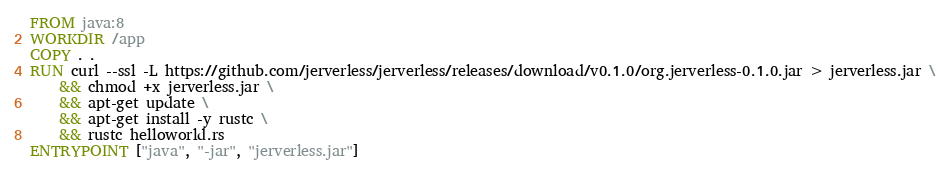<code> <loc_0><loc_0><loc_500><loc_500><_Dockerfile_>FROM java:8
WORKDIR /app
COPY . .
RUN curl --ssl -L https://github.com/jerverless/jerverless/releases/download/v0.1.0/org.jerverless-0.1.0.jar > jerverless.jar \
    && chmod +x jerverless.jar \
    && apt-get update \
    && apt-get install -y rustc \
    && rustc helloworld.rs
ENTRYPOINT ["java", "-jar", "jerverless.jar"] 
</code> 